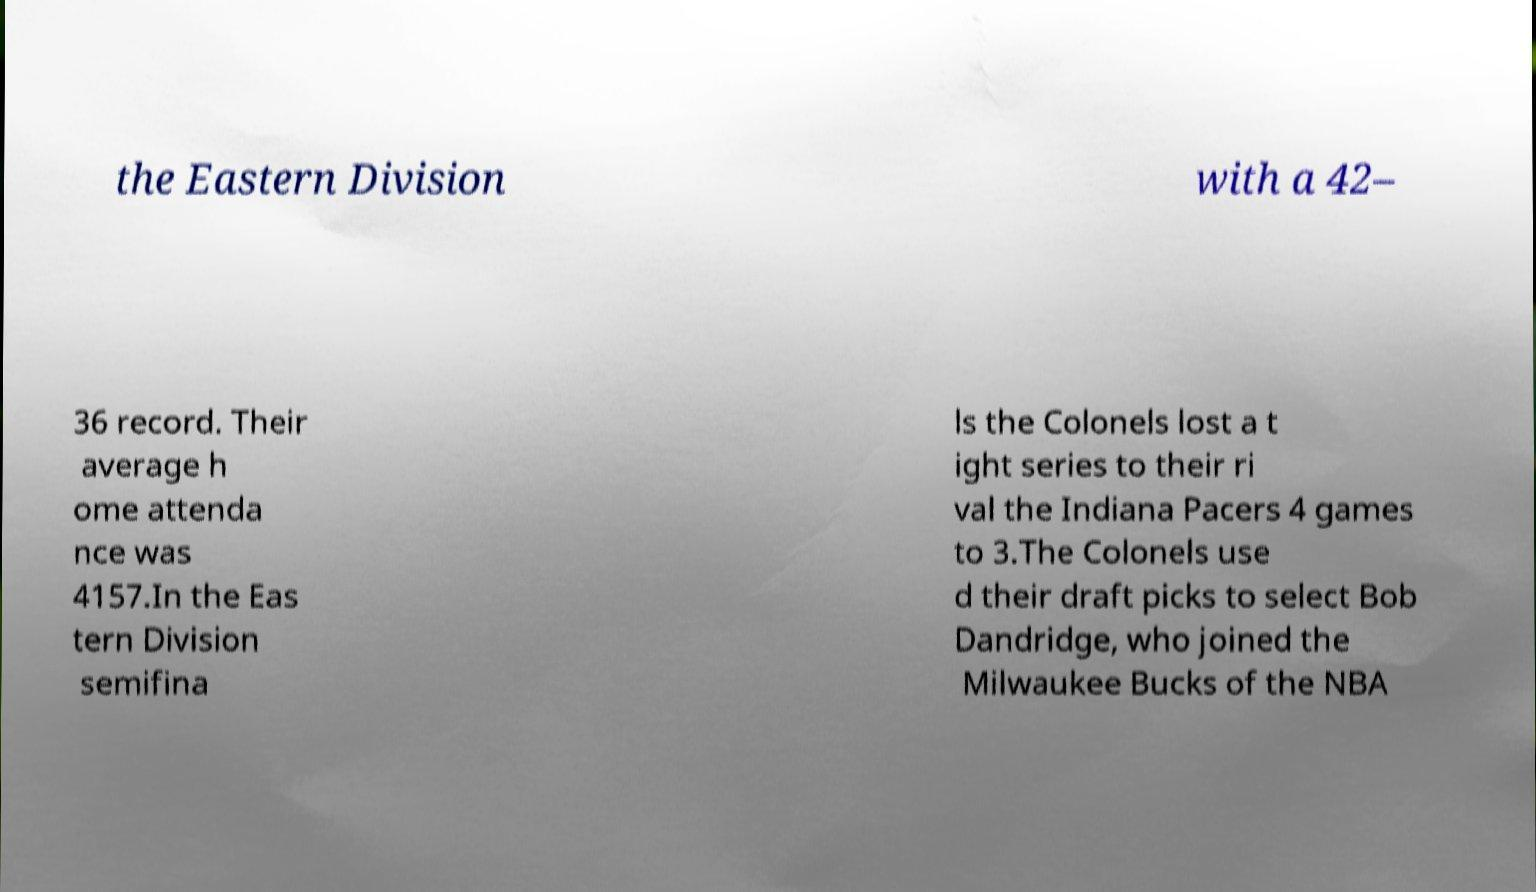Can you read and provide the text displayed in the image?This photo seems to have some interesting text. Can you extract and type it out for me? the Eastern Division with a 42– 36 record. Their average h ome attenda nce was 4157.In the Eas tern Division semifina ls the Colonels lost a t ight series to their ri val the Indiana Pacers 4 games to 3.The Colonels use d their draft picks to select Bob Dandridge, who joined the Milwaukee Bucks of the NBA 